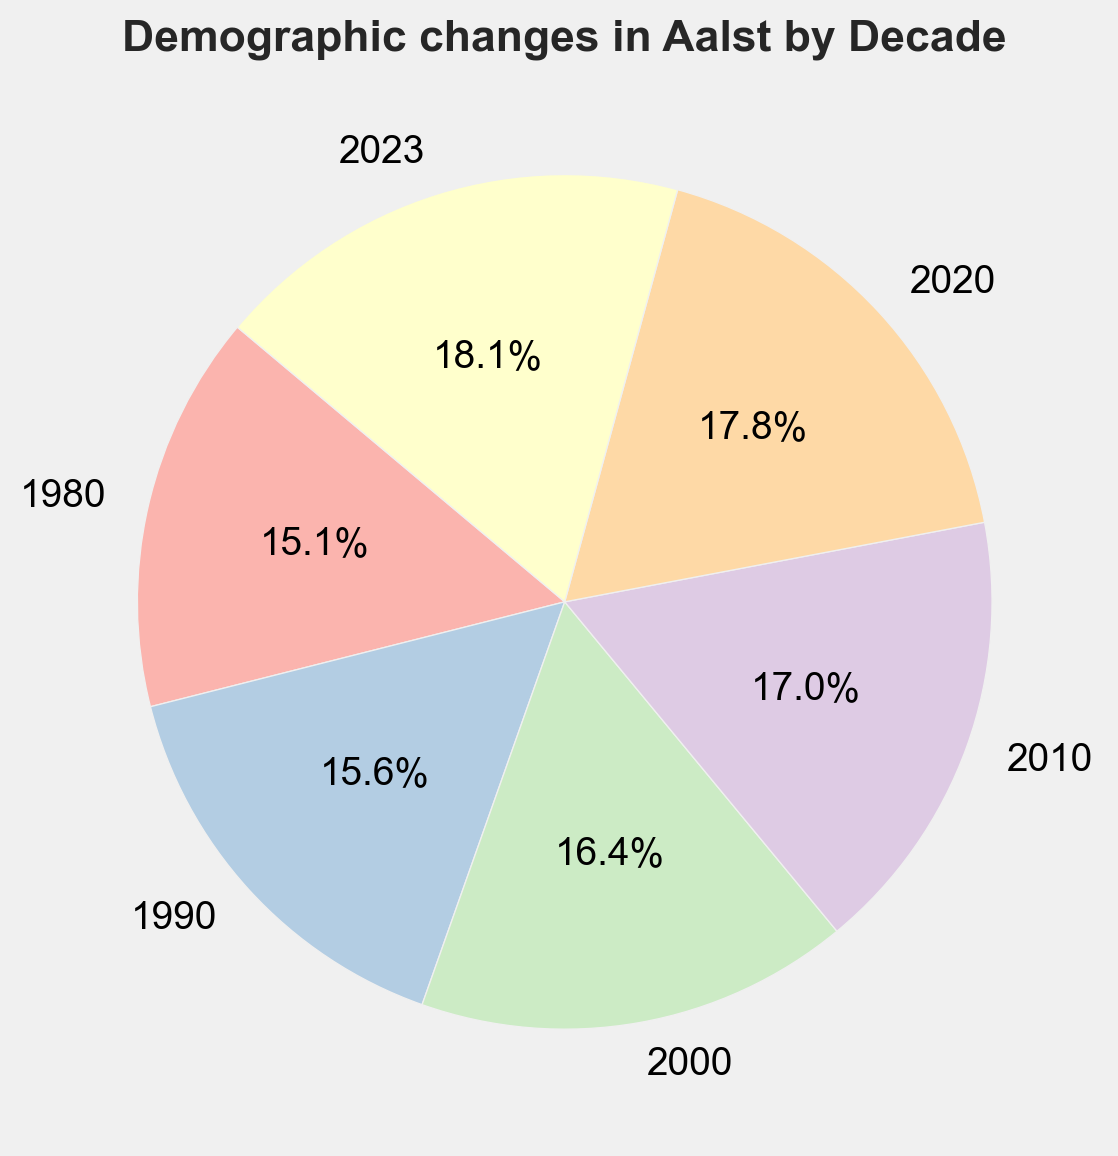What is the smallest population shown on the pie chart? The smallest population can be identified by looking at the segment with the smallest percentage. The segment labeled "1980" shows the population as 78,000, which is the smallest.
Answer: 78,000 What is the total population in 2023 and 1980 combined? Add the population from 2023 and 1980. By referring to the pie chart, the populations are 94,000 and 78,000 respectively. Summing these gives 94,000 + 78,000 = 172,000.
Answer: 172,000 Which decade experienced the largest population increase from the previous decade? Calculate the population increase for each decade and compare. The increases are:
1980-1990: 81,000 - 78,000 = 3,000
1990-2000: 85,000 - 81,000 = 4,000
2000-2010: 88,000 - 85,000 = 3,000
2010-2020: 92,000 - 88,000 = 4,000
2020-2023: 94,000 - 92,000 = 2,000
The largest increase was between 1990 and 2000, and equally between 2010 to 2020, with an increase of 4,000 each.
Answer: 1990-2000 and 2010-2020 What percentage of the total does the population in 2000 represent? The pie chart shows the percentage of each segment, with the segment labeled "2000" showing a specific percentage. Add the given populations of all decades first to find the total: 78,000 + 81,000 + 85,000 + 88,000 + 92,000 + 94,000 = 518,000. Calculate the percentage for 2000: (85,000 / 518,000) * 100 = approximately 16.4%.
Answer: 16.4% Which decade has a population closest to 90,000? The pie chart shows segment sizes for each decade. The segment labeled "2020" has a population of 92,000, which is the closest to 90,000.
Answer: 2020 What is the average population over the decades shown? Calculate the mean population across all given decades. Sum the population values and divide by the number of decades: (78,000 + 81,000 + 85,000 + 88,000 + 92,000 + 94,000) / 6 = 518,000 / 6 = approximately 86,333.
Answer: 86,333 Which decade had the least percentage increase in population compared to the previous decade? Calculate percentage increases for each decade:
1980-1990: (81,000 - 78,000) / 78,000 * 100 = 3.85%
1990-2000: (85,000 - 81,000) / 81,000 * 100 = 4.94%
2000-2010: (88,000 - 85,000) / 85,000 * 100 = 3.53%
2010-2020: (92,000 - 88,000) / 88,000 * 100 = 4.55%
2020-2023: (94,000 - 92,000) / 92,000 * 100 = 2.17%
The least percentage increase is between 2020 and 2023 with 2.17%.
Answer: 2020-2023 